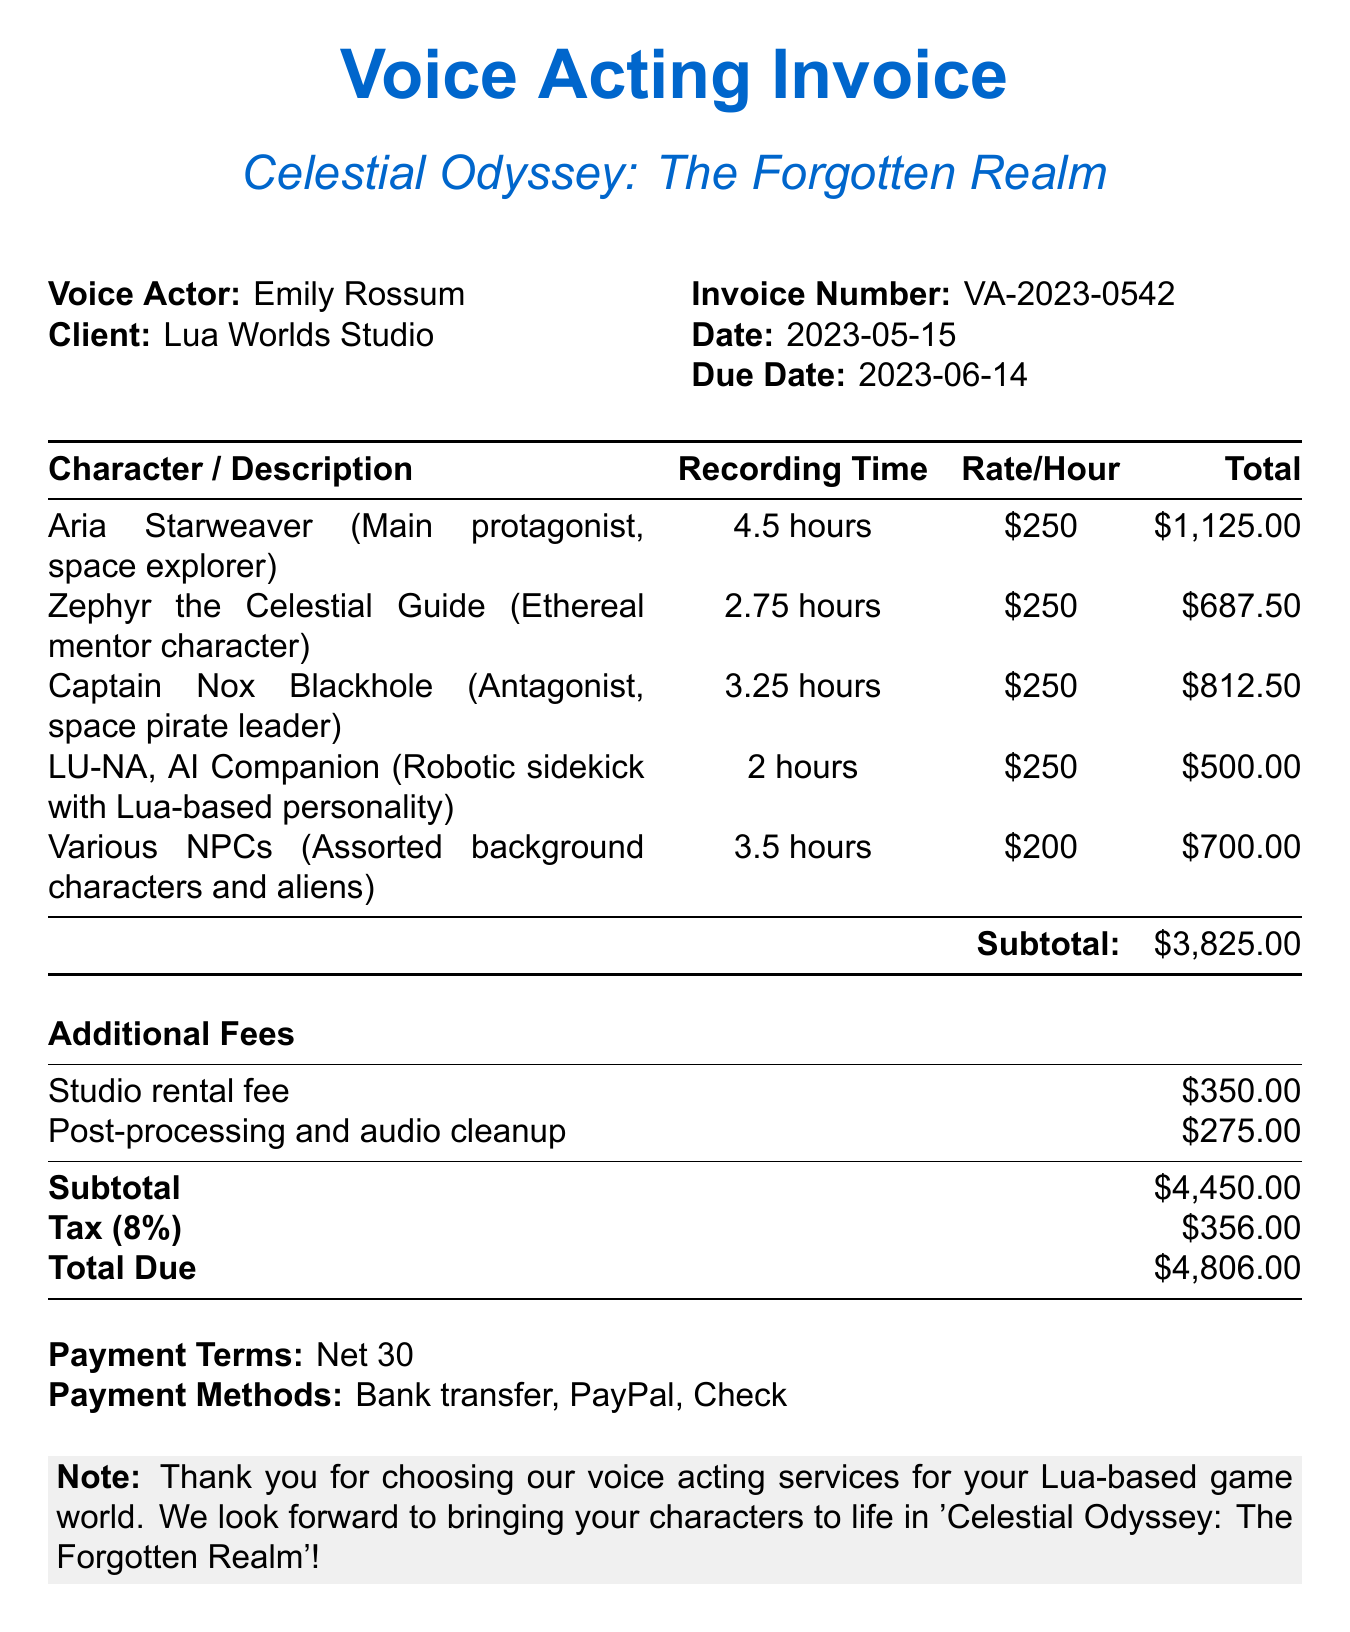What is the invoice number? The invoice number is explicitly stated in the document as "VA-2023-0542".
Answer: VA-2023-0542 Who is the voice actor? The document clearly indicates that the voice actor is "Emily Rossum".
Answer: Emily Rossum What is the total due amount? The total due amount is provided at the end of the document and is "$4,806.00".
Answer: $4,806.00 What is the recording time for Aria Starweaver? The document specifies that the recording time for Aria Starweaver is "4.5 hours".
Answer: 4.5 hours What is the rate per hour for the characters? The document states the rate per hour for the characters is "$250" in most cases, except for Various NPCs.
Answer: $250 How many additional fees are listed? The document lists two additional fees, which can be counted directly from the additional fees section.
Answer: 2 What is the payment term? The payment term is mentioned in the document and is "Net 30".
Answer: Net 30 Who is the client? The client is specified in the document as "Lua Worlds Studio".
Answer: Lua Worlds Studio What character is an antagonist? The document identifies Captain Nox Blackhole as the antagonist.
Answer: Captain Nox Blackhole 